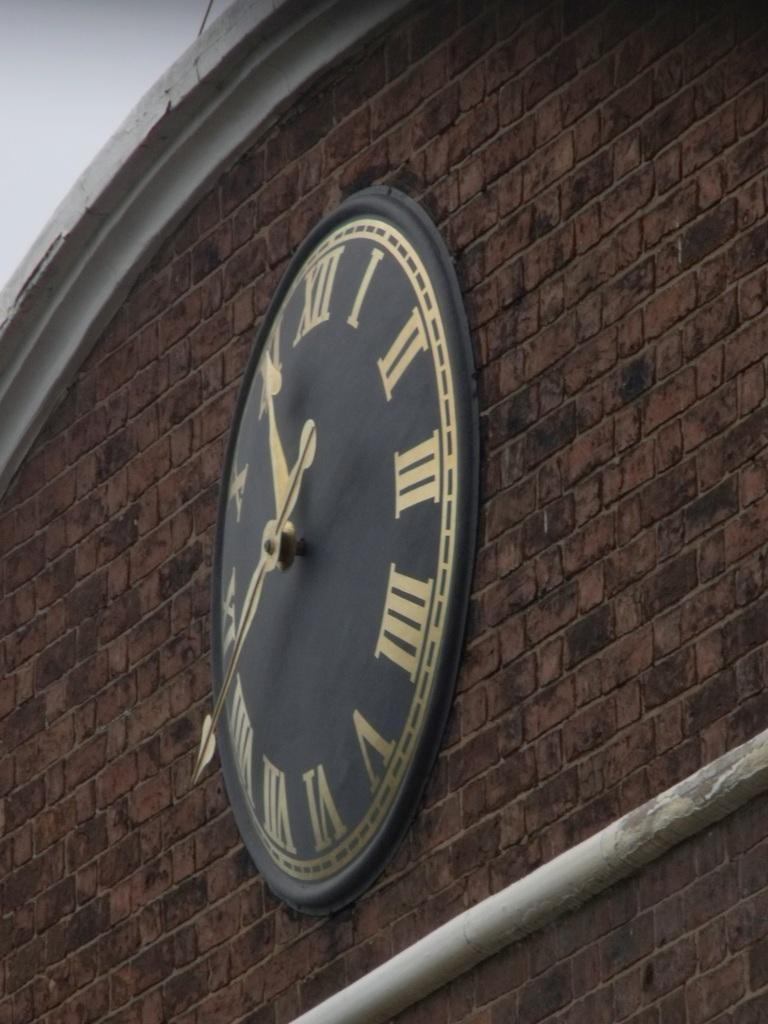<image>
Create a compact narrative representing the image presented. Roman numeral clock with the hands at 11:40 on a brick wall. 